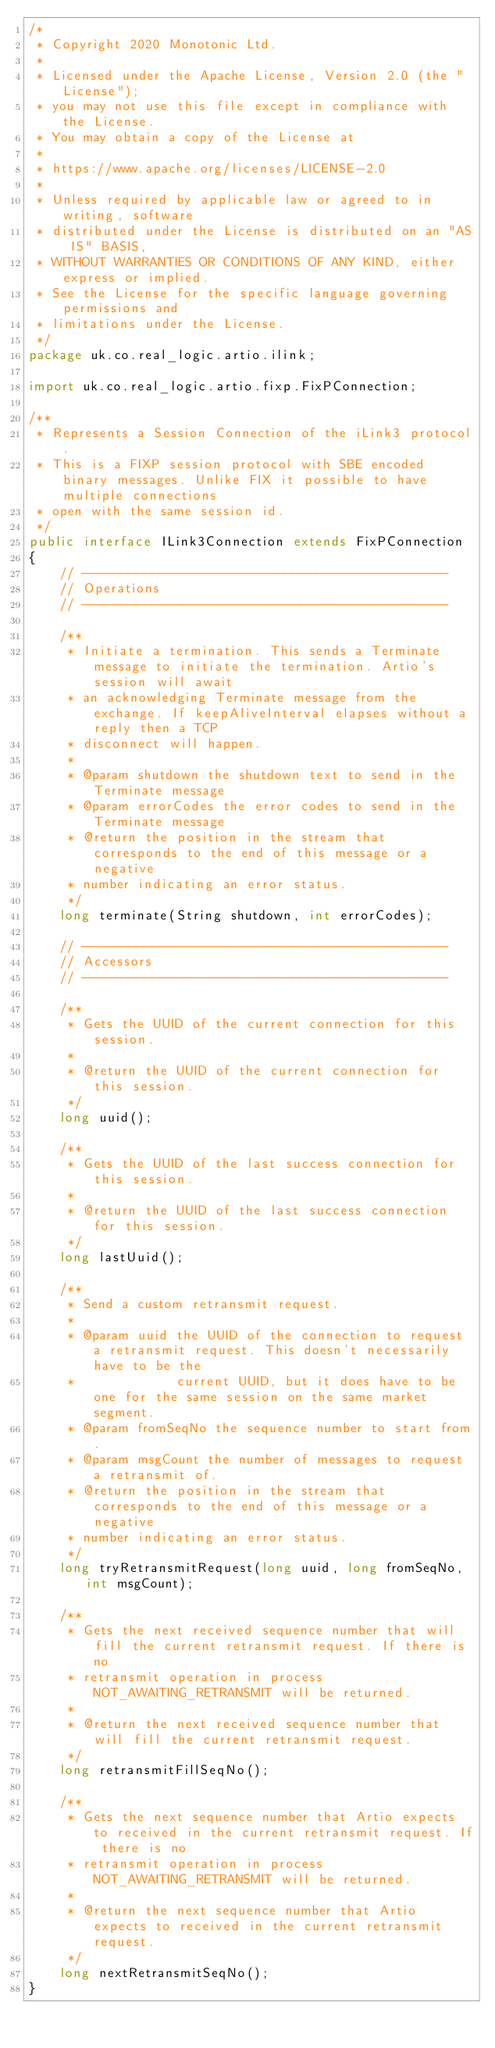<code> <loc_0><loc_0><loc_500><loc_500><_Java_>/*
 * Copyright 2020 Monotonic Ltd.
 *
 * Licensed under the Apache License, Version 2.0 (the "License");
 * you may not use this file except in compliance with the License.
 * You may obtain a copy of the License at
 *
 * https://www.apache.org/licenses/LICENSE-2.0
 *
 * Unless required by applicable law or agreed to in writing, software
 * distributed under the License is distributed on an "AS IS" BASIS,
 * WITHOUT WARRANTIES OR CONDITIONS OF ANY KIND, either express or implied.
 * See the License for the specific language governing permissions and
 * limitations under the License.
 */
package uk.co.real_logic.artio.ilink;

import uk.co.real_logic.artio.fixp.FixPConnection;

/**
 * Represents a Session Connection of the iLink3 protocol.
 * This is a FIXP session protocol with SBE encoded binary messages. Unlike FIX it possible to have multiple connections
 * open with the same session id.
 */
public interface ILink3Connection extends FixPConnection
{
    // -----------------------------------------------
    // Operations
    // -----------------------------------------------

    /**
     * Initiate a termination. This sends a Terminate message to initiate the termination. Artio's session will await
     * an acknowledging Terminate message from the exchange. If keepAliveInterval elapses without a reply then a TCP
     * disconnect will happen.
     *
     * @param shutdown the shutdown text to send in the Terminate message
     * @param errorCodes the error codes to send in the Terminate message
     * @return the position in the stream that corresponds to the end of this message or a negative
     * number indicating an error status.
     */
    long terminate(String shutdown, int errorCodes);

    // -----------------------------------------------
    // Accessors
    // -----------------------------------------------

    /**
     * Gets the UUID of the current connection for this session.
     *
     * @return the UUID of the current connection for this session.
     */
    long uuid();

    /**
     * Gets the UUID of the last success connection for this session.
     *
     * @return the UUID of the last success connection for this session.
     */
    long lastUuid();

    /**
     * Send a custom retransmit request.
     *
     * @param uuid the UUID of the connection to request a retransmit request. This doesn't necessarily have to be the
     *             current UUID, but it does have to be one for the same session on the same market segment.
     * @param fromSeqNo the sequence number to start from.
     * @param msgCount the number of messages to request a retransmit of.
     * @return the position in the stream that corresponds to the end of this message or a negative
     * number indicating an error status.
     */
    long tryRetransmitRequest(long uuid, long fromSeqNo, int msgCount);

    /**
     * Gets the next received sequence number that will fill the current retransmit request. If there is no
     * retransmit operation in process NOT_AWAITING_RETRANSMIT will be returned.
     *
     * @return the next received sequence number that will fill the current retransmit request.
     */
    long retransmitFillSeqNo();

    /**
     * Gets the next sequence number that Artio expects to received in the current retransmit request. If there is no
     * retransmit operation in process NOT_AWAITING_RETRANSMIT will be returned.
     *
     * @return the next sequence number that Artio expects to received in the current retransmit request.
     */
    long nextRetransmitSeqNo();
}
</code> 